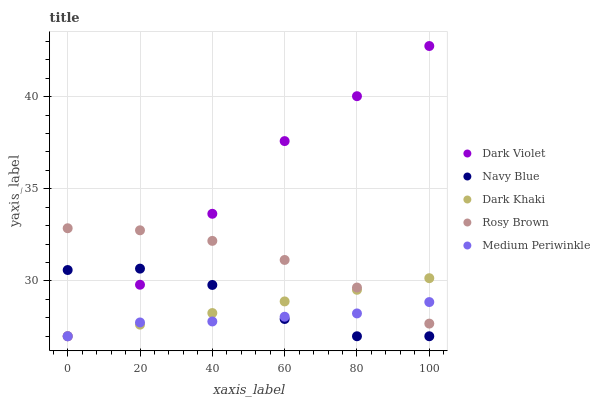Does Medium Periwinkle have the minimum area under the curve?
Answer yes or no. Yes. Does Dark Violet have the maximum area under the curve?
Answer yes or no. Yes. Does Navy Blue have the minimum area under the curve?
Answer yes or no. No. Does Navy Blue have the maximum area under the curve?
Answer yes or no. No. Is Dark Khaki the smoothest?
Answer yes or no. Yes. Is Navy Blue the roughest?
Answer yes or no. Yes. Is Rosy Brown the smoothest?
Answer yes or no. No. Is Rosy Brown the roughest?
Answer yes or no. No. Does Dark Khaki have the lowest value?
Answer yes or no. Yes. Does Rosy Brown have the lowest value?
Answer yes or no. No. Does Dark Violet have the highest value?
Answer yes or no. Yes. Does Navy Blue have the highest value?
Answer yes or no. No. Is Navy Blue less than Rosy Brown?
Answer yes or no. Yes. Is Rosy Brown greater than Navy Blue?
Answer yes or no. Yes. Does Navy Blue intersect Dark Violet?
Answer yes or no. Yes. Is Navy Blue less than Dark Violet?
Answer yes or no. No. Is Navy Blue greater than Dark Violet?
Answer yes or no. No. Does Navy Blue intersect Rosy Brown?
Answer yes or no. No. 